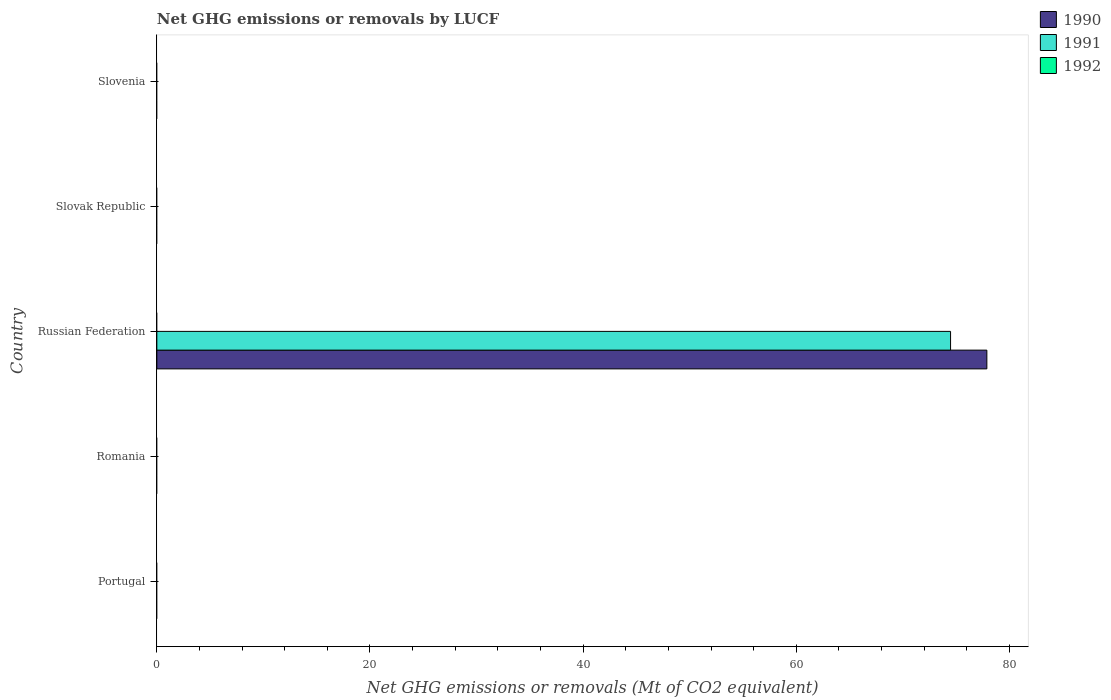How many bars are there on the 3rd tick from the top?
Give a very brief answer. 2. What is the label of the 4th group of bars from the top?
Your answer should be very brief. Romania. In how many cases, is the number of bars for a given country not equal to the number of legend labels?
Offer a very short reply. 5. What is the net GHG emissions or removals by LUCF in 1991 in Slovenia?
Offer a terse response. 0. Across all countries, what is the maximum net GHG emissions or removals by LUCF in 1990?
Give a very brief answer. 77.88. Across all countries, what is the minimum net GHG emissions or removals by LUCF in 1992?
Provide a succinct answer. 0. In which country was the net GHG emissions or removals by LUCF in 1991 maximum?
Your response must be concise. Russian Federation. What is the total net GHG emissions or removals by LUCF in 1990 in the graph?
Ensure brevity in your answer.  77.88. What is the difference between the net GHG emissions or removals by LUCF in 1991 in Russian Federation and the net GHG emissions or removals by LUCF in 1990 in Slovenia?
Your answer should be very brief. 74.48. What is the average net GHG emissions or removals by LUCF in 1992 per country?
Ensure brevity in your answer.  0. What is the difference between the net GHG emissions or removals by LUCF in 1990 and net GHG emissions or removals by LUCF in 1991 in Russian Federation?
Your answer should be compact. 3.41. In how many countries, is the net GHG emissions or removals by LUCF in 1991 greater than 24 Mt?
Offer a terse response. 1. What is the difference between the highest and the lowest net GHG emissions or removals by LUCF in 1991?
Your response must be concise. 74.48. In how many countries, is the net GHG emissions or removals by LUCF in 1992 greater than the average net GHG emissions or removals by LUCF in 1992 taken over all countries?
Offer a terse response. 0. Are all the bars in the graph horizontal?
Your answer should be compact. Yes. How many countries are there in the graph?
Make the answer very short. 5. Does the graph contain any zero values?
Offer a very short reply. Yes. Does the graph contain grids?
Offer a terse response. No. What is the title of the graph?
Ensure brevity in your answer.  Net GHG emissions or removals by LUCF. Does "1992" appear as one of the legend labels in the graph?
Provide a succinct answer. Yes. What is the label or title of the X-axis?
Provide a succinct answer. Net GHG emissions or removals (Mt of CO2 equivalent). What is the Net GHG emissions or removals (Mt of CO2 equivalent) in 1990 in Portugal?
Offer a terse response. 0. What is the Net GHG emissions or removals (Mt of CO2 equivalent) in 1990 in Romania?
Provide a succinct answer. 0. What is the Net GHG emissions or removals (Mt of CO2 equivalent) of 1991 in Romania?
Your answer should be compact. 0. What is the Net GHG emissions or removals (Mt of CO2 equivalent) of 1990 in Russian Federation?
Offer a terse response. 77.88. What is the Net GHG emissions or removals (Mt of CO2 equivalent) of 1991 in Russian Federation?
Keep it short and to the point. 74.48. What is the Net GHG emissions or removals (Mt of CO2 equivalent) in 1992 in Russian Federation?
Provide a short and direct response. 0. What is the Net GHG emissions or removals (Mt of CO2 equivalent) of 1992 in Slovak Republic?
Make the answer very short. 0. What is the Net GHG emissions or removals (Mt of CO2 equivalent) of 1990 in Slovenia?
Provide a short and direct response. 0. What is the Net GHG emissions or removals (Mt of CO2 equivalent) in 1991 in Slovenia?
Provide a short and direct response. 0. What is the Net GHG emissions or removals (Mt of CO2 equivalent) of 1992 in Slovenia?
Give a very brief answer. 0. Across all countries, what is the maximum Net GHG emissions or removals (Mt of CO2 equivalent) in 1990?
Your response must be concise. 77.88. Across all countries, what is the maximum Net GHG emissions or removals (Mt of CO2 equivalent) in 1991?
Your answer should be very brief. 74.48. Across all countries, what is the minimum Net GHG emissions or removals (Mt of CO2 equivalent) in 1990?
Ensure brevity in your answer.  0. Across all countries, what is the minimum Net GHG emissions or removals (Mt of CO2 equivalent) in 1991?
Your answer should be compact. 0. What is the total Net GHG emissions or removals (Mt of CO2 equivalent) in 1990 in the graph?
Offer a terse response. 77.89. What is the total Net GHG emissions or removals (Mt of CO2 equivalent) in 1991 in the graph?
Make the answer very short. 74.48. What is the total Net GHG emissions or removals (Mt of CO2 equivalent) in 1992 in the graph?
Offer a very short reply. 0. What is the average Net GHG emissions or removals (Mt of CO2 equivalent) of 1990 per country?
Your answer should be compact. 15.58. What is the average Net GHG emissions or removals (Mt of CO2 equivalent) in 1991 per country?
Keep it short and to the point. 14.9. What is the difference between the Net GHG emissions or removals (Mt of CO2 equivalent) of 1990 and Net GHG emissions or removals (Mt of CO2 equivalent) of 1991 in Russian Federation?
Offer a terse response. 3.41. What is the difference between the highest and the lowest Net GHG emissions or removals (Mt of CO2 equivalent) of 1990?
Ensure brevity in your answer.  77.89. What is the difference between the highest and the lowest Net GHG emissions or removals (Mt of CO2 equivalent) of 1991?
Your answer should be compact. 74.48. 